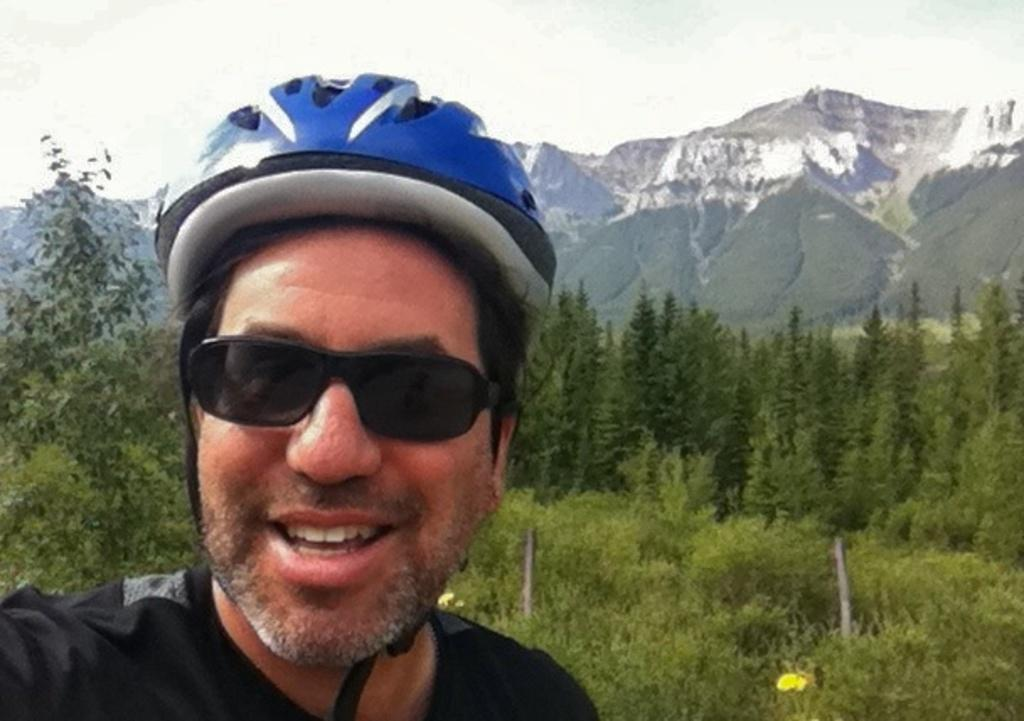Who is the main subject in the foreground of the image? There is a man in the foreground of the image. What can be seen in the background of the image? There are many plants and trees, as well as mountains, visible in the background of the image. What type of linen is draped over the man's shoulders in the image? There is no linen draped over the man's shoulders in the image. Can you see any insects crawling on the plants in the image? There is no mention of insects in the image, so we cannot determine if any are present. 